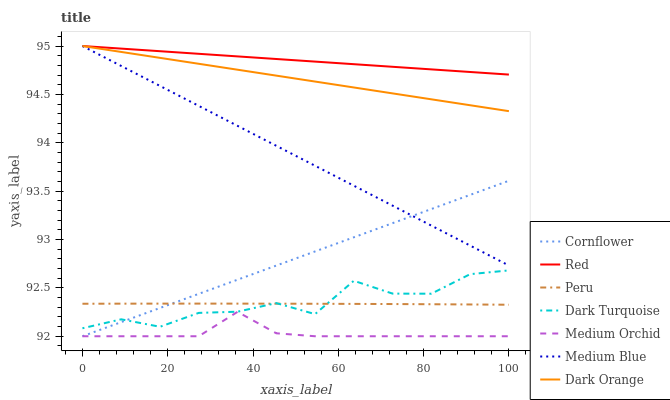Does Medium Orchid have the minimum area under the curve?
Answer yes or no. Yes. Does Red have the maximum area under the curve?
Answer yes or no. Yes. Does Dark Orange have the minimum area under the curve?
Answer yes or no. No. Does Dark Orange have the maximum area under the curve?
Answer yes or no. No. Is Cornflower the smoothest?
Answer yes or no. Yes. Is Dark Turquoise the roughest?
Answer yes or no. Yes. Is Dark Orange the smoothest?
Answer yes or no. No. Is Dark Orange the roughest?
Answer yes or no. No. Does Cornflower have the lowest value?
Answer yes or no. Yes. Does Dark Orange have the lowest value?
Answer yes or no. No. Does Red have the highest value?
Answer yes or no. Yes. Does Dark Turquoise have the highest value?
Answer yes or no. No. Is Medium Orchid less than Peru?
Answer yes or no. Yes. Is Dark Turquoise greater than Medium Orchid?
Answer yes or no. Yes. Does Dark Turquoise intersect Peru?
Answer yes or no. Yes. Is Dark Turquoise less than Peru?
Answer yes or no. No. Is Dark Turquoise greater than Peru?
Answer yes or no. No. Does Medium Orchid intersect Peru?
Answer yes or no. No. 